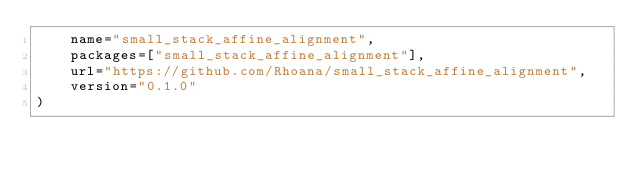Convert code to text. <code><loc_0><loc_0><loc_500><loc_500><_Python_>    name="small_stack_affine_alignment",
    packages=["small_stack_affine_alignment"],
    url="https://github.com/Rhoana/small_stack_affine_alignment",
    version="0.1.0"
)
</code> 